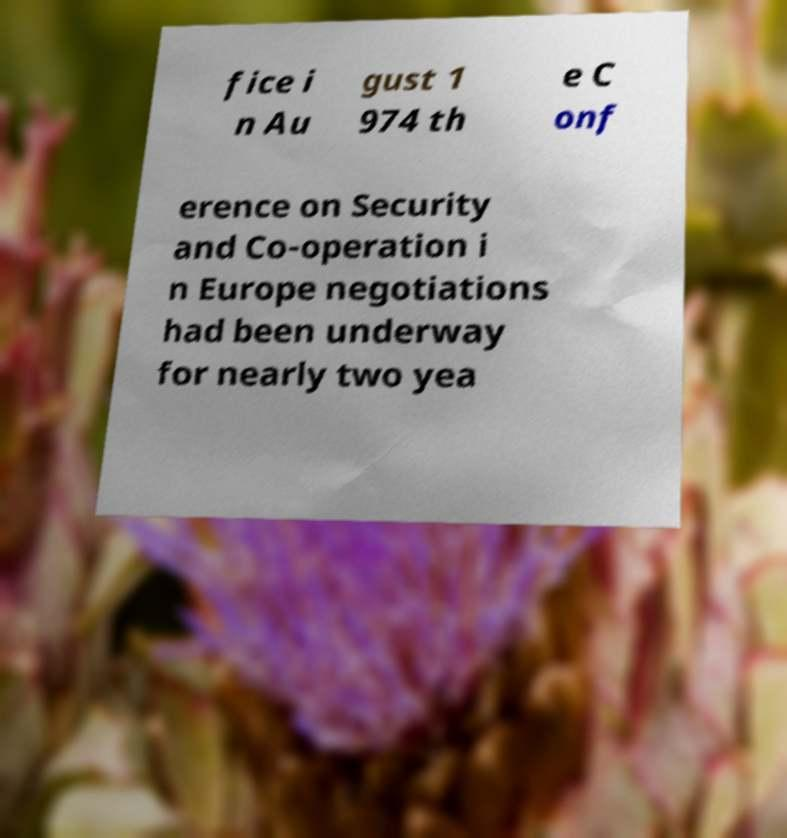There's text embedded in this image that I need extracted. Can you transcribe it verbatim? fice i n Au gust 1 974 th e C onf erence on Security and Co-operation i n Europe negotiations had been underway for nearly two yea 